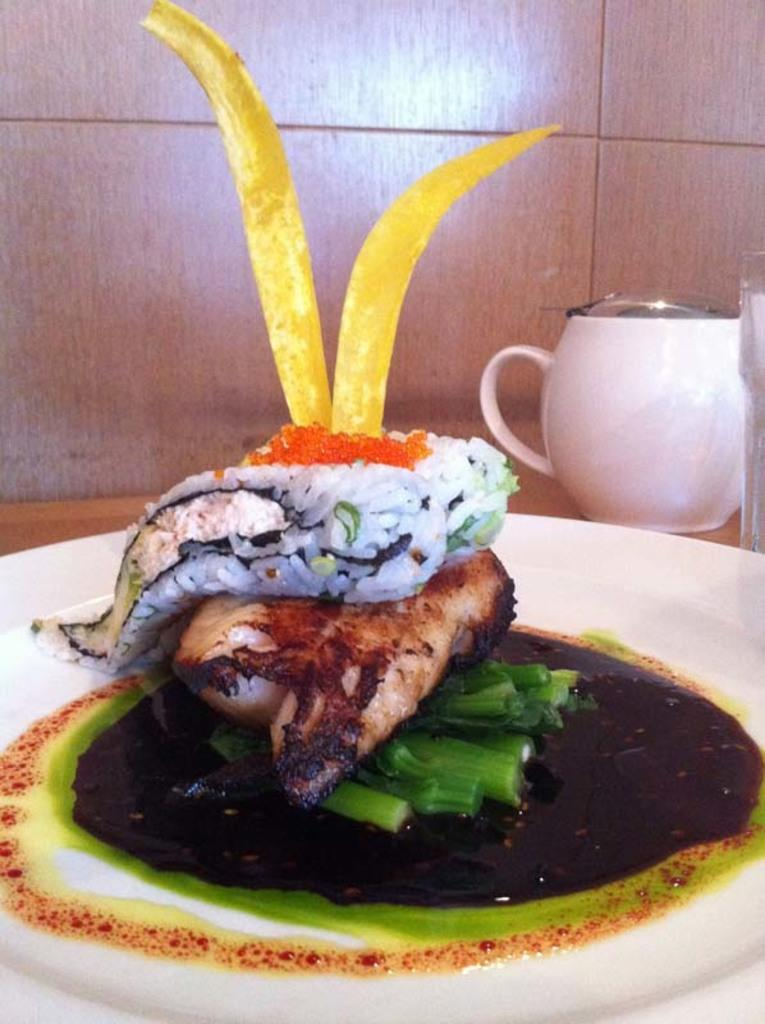What is on the plate in the image? There is food in a plate in the image. What other objects can be seen in the image? There is a jar and a glass in the image. Where are the food, jar, and glass placed? They are placed on a surface. What can be seen in the background of the image? There is a wall visible in the background of the image. Where is the library located in the image? There is no library present in the image. What type of throne can be seen in the image? There is no throne present in the image. 